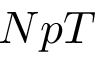Convert formula to latex. <formula><loc_0><loc_0><loc_500><loc_500>N p T</formula> 